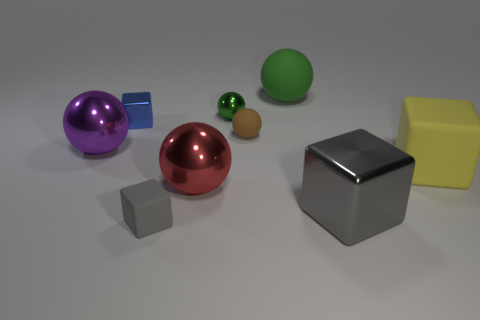Subtract all red balls. How many balls are left? 4 Subtract all big yellow matte cubes. How many cubes are left? 3 Add 1 yellow matte blocks. How many objects exist? 10 Subtract 2 spheres. How many spheres are left? 3 Subtract all purple cubes. Subtract all green spheres. How many cubes are left? 4 Subtract all gray cylinders. How many purple spheres are left? 1 Subtract all balls. How many objects are left? 4 Subtract all big blue cubes. Subtract all small blue objects. How many objects are left? 8 Add 6 large purple metallic objects. How many large purple metallic objects are left? 7 Add 6 yellow rubber spheres. How many yellow rubber spheres exist? 6 